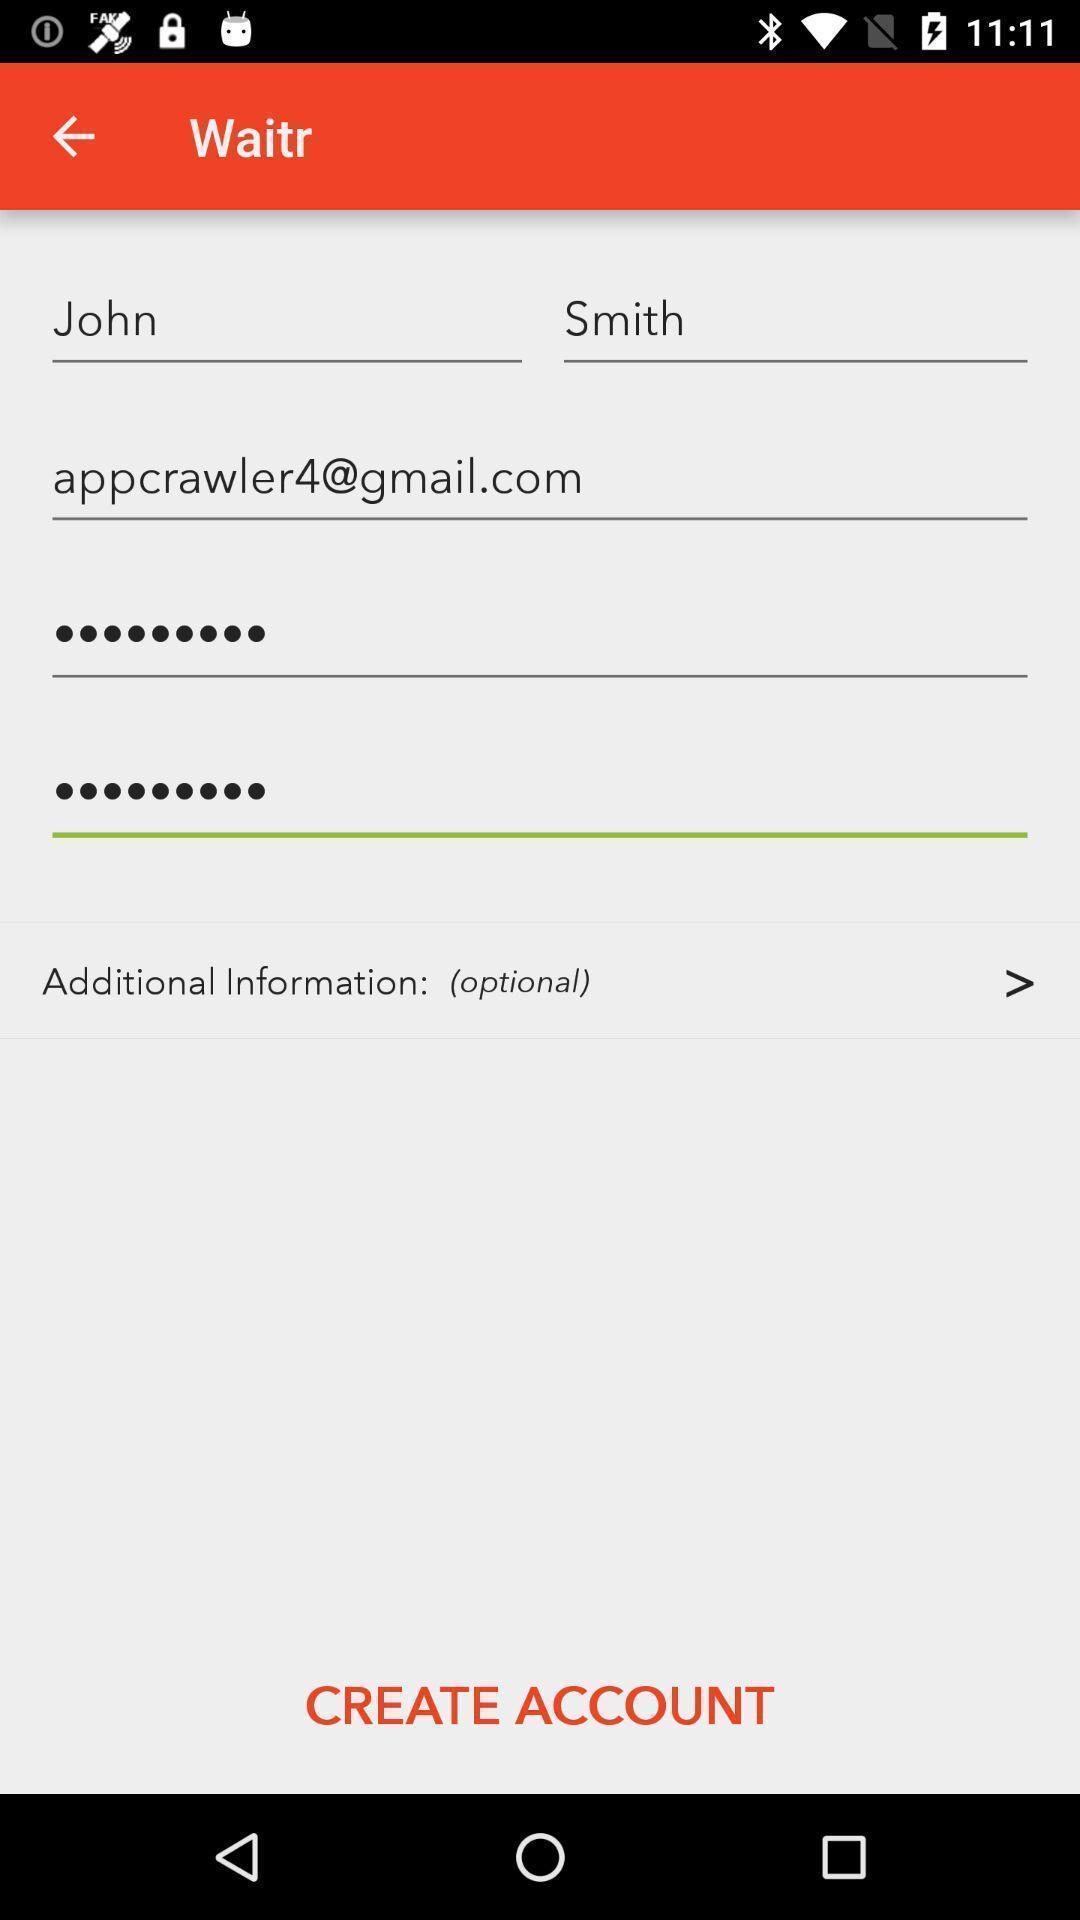Explain the elements present in this screenshot. Profile information updating in this page. 